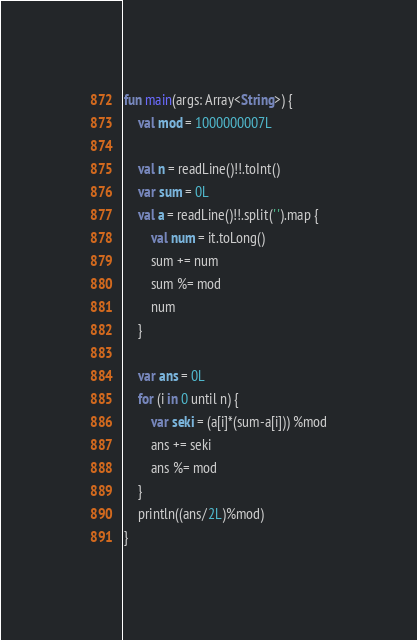Convert code to text. <code><loc_0><loc_0><loc_500><loc_500><_Kotlin_>fun main(args: Array<String>) {
    val mod = 1000000007L

    val n = readLine()!!.toInt()
    var sum = 0L
    val a = readLine()!!.split(' ').map {
        val num = it.toLong()
        sum += num
        sum %= mod
        num
    }

    var ans = 0L
    for (i in 0 until n) {
        var seki = (a[i]*(sum-a[i])) %mod
        ans += seki
        ans %= mod
    }
    println((ans/2L)%mod)
}
</code> 